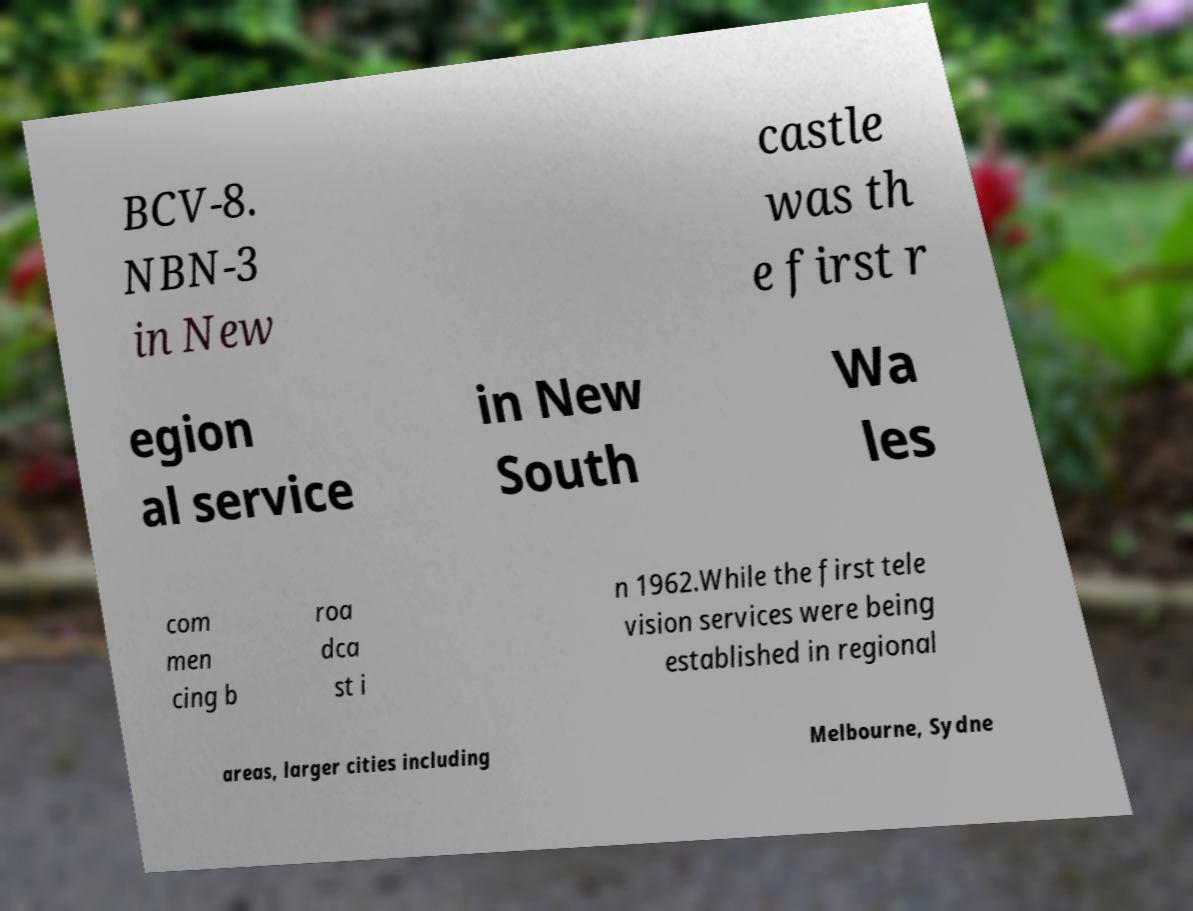Can you read and provide the text displayed in the image?This photo seems to have some interesting text. Can you extract and type it out for me? BCV-8. NBN-3 in New castle was th e first r egion al service in New South Wa les com men cing b roa dca st i n 1962.While the first tele vision services were being established in regional areas, larger cities including Melbourne, Sydne 